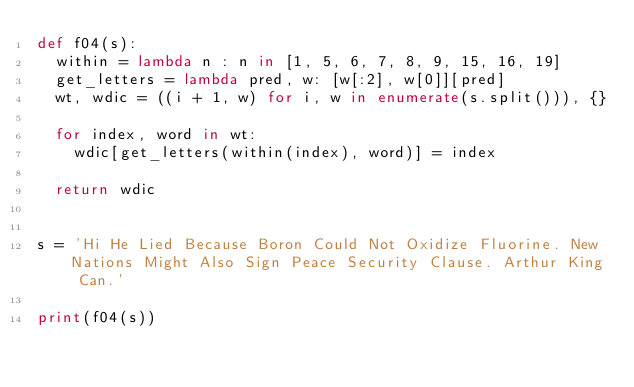<code> <loc_0><loc_0><loc_500><loc_500><_Python_>def f04(s):
  within = lambda n : n in [1, 5, 6, 7, 8, 9, 15, 16, 19]
  get_letters = lambda pred, w: [w[:2], w[0]][pred]
  wt, wdic = ((i + 1, w) for i, w in enumerate(s.split())), {}
  
  for index, word in wt:
    wdic[get_letters(within(index), word)] = index

  return wdic


s = 'Hi He Lied Because Boron Could Not Oxidize Fluorine. New Nations Might Also Sign Peace Security Clause. Arthur King Can.'

print(f04(s))</code> 